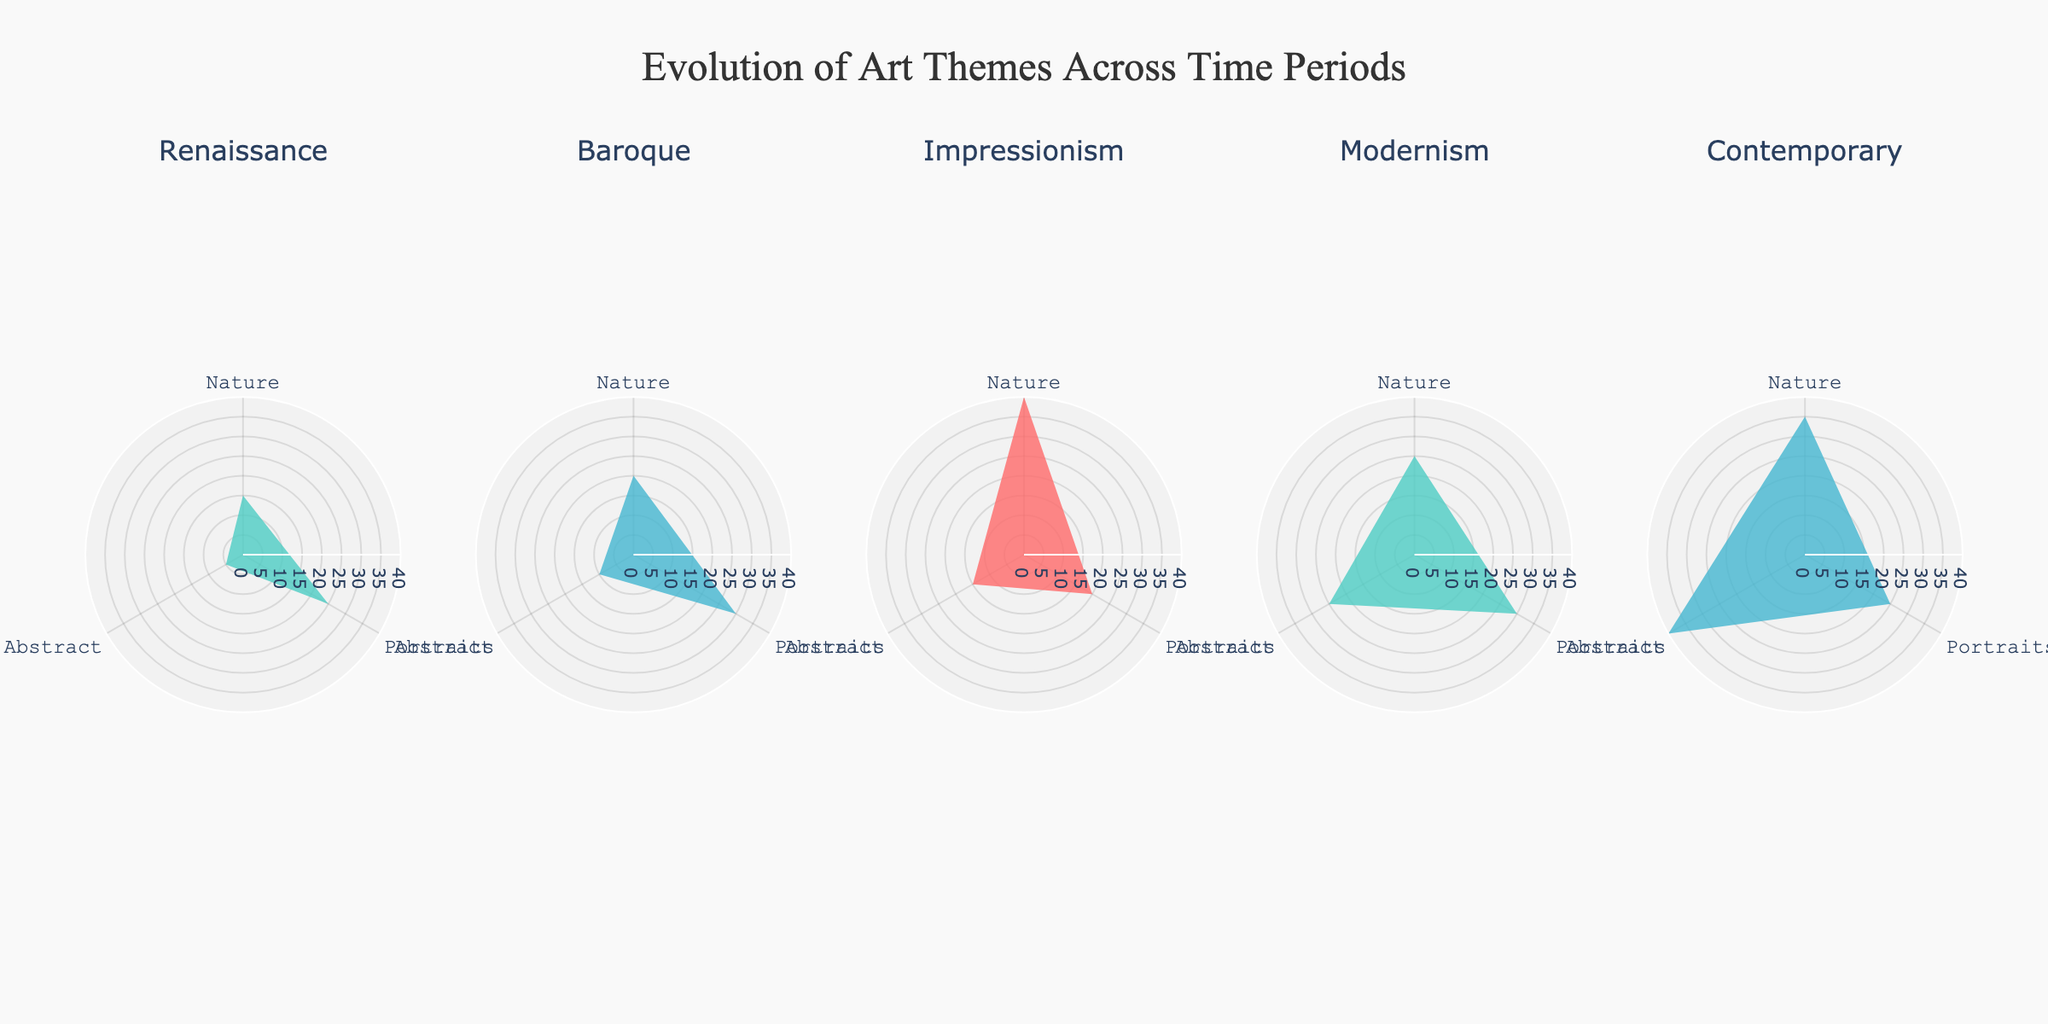what is the title of this figure? The title is displayed at the top of the figure and provides a summary of what the visual represents. It reads "Evolution of Art Themes Across Time Periods".
Answer: Evolution of Art Themes Across Time Periods What are the themes represented in this figure? The themes are distributed in the polar charts as distinct categories. They are labeled along the angular axis. The themes shown are "Nature", "Portraits", and "Abstract".
Answer: Nature, Portraits, Abstract How many time periods are compared in the subplots? There are multiple polar charts, one for each time period, indicated by the subplot titles. They are "Renaissance", "Baroque", "Impressionism", "Modernism", and "Contemporary".
Answer: Five Which theme had the highest representation during the Impressionism time period? In the subplot for Impressionism, the radial axis values indicate that "Nature" has the highest value among themes.
Answer: Nature In which time period did Abstract art have the lowest number of artworks? By examining the radial values for "Abstract" in each subplot, Renaissance has the lowest number of artworks for Abstract with a value of 5.
Answer: Renaissance How does the number of "Portraits" artworks in the Baroque period compare to the Contemporary period? By checking the radial axis values for "Portraits" in both periods, Baroque has 30, whereas Contemporary has 25. Therefore, Baroque has more than Contemporary.
Answer: Baroque > Contemporary What is the average number of Nature-themed artworks over all time periods? Summing the Nature values (15 + 20 + 40 + 25 + 35) gives 135. Dividing by the number of periods (5) results in an average of 27.
Answer: 27 Which two themes' artworks in the Modernism period have the same representation? In the Modernism subplot, both "Portraits" and "Abstract" have the same radial value of 30.
Answer: Portraits and Abstract Which time period shows the most balanced distribution (least difference between the themes) of artworks among the three themes? Comparing the difference between the highest and lowest radial values for each time period, Renaissance has the least difference where Nature=15, Portraits=25, Abstract=5, giving a range of 20.
Answer: Renaissance What is the total number of artworks for "Abstract" art across all periods? Adding up the values for Abstract from all periods: 5 (Renaissance) + 10 (Baroque) + 15 (Impressionism) + 25 (Modernism) + 40 (Contemporary) = 95.
Answer: 95 